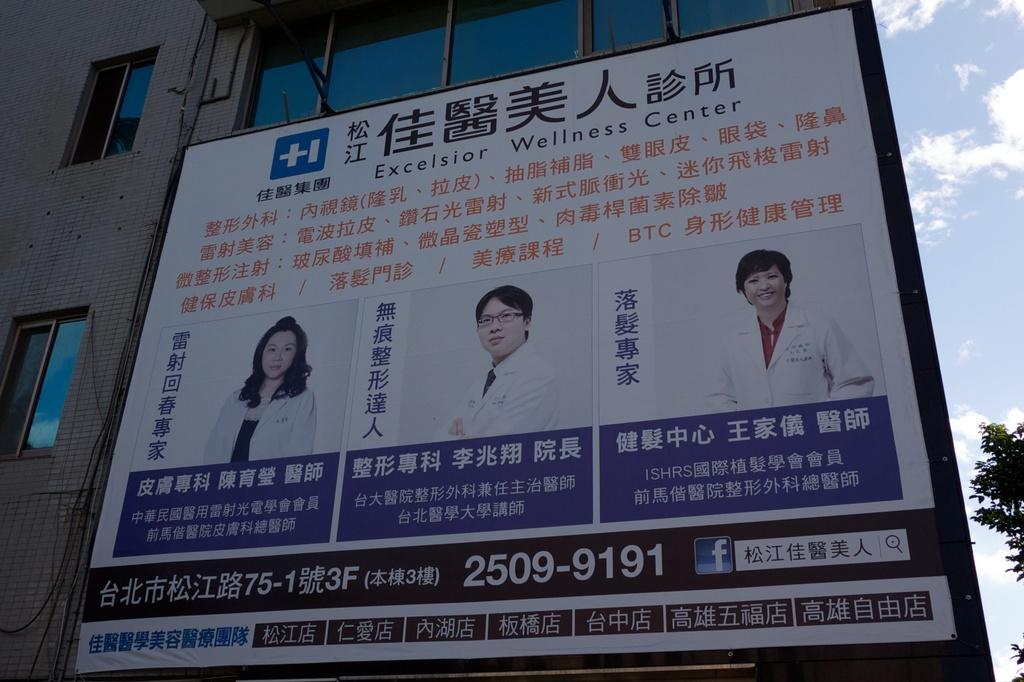Provide a one-sentence caption for the provided image. A large Chinese sign near a building with pictures of a woman doctor and two male doctors . 